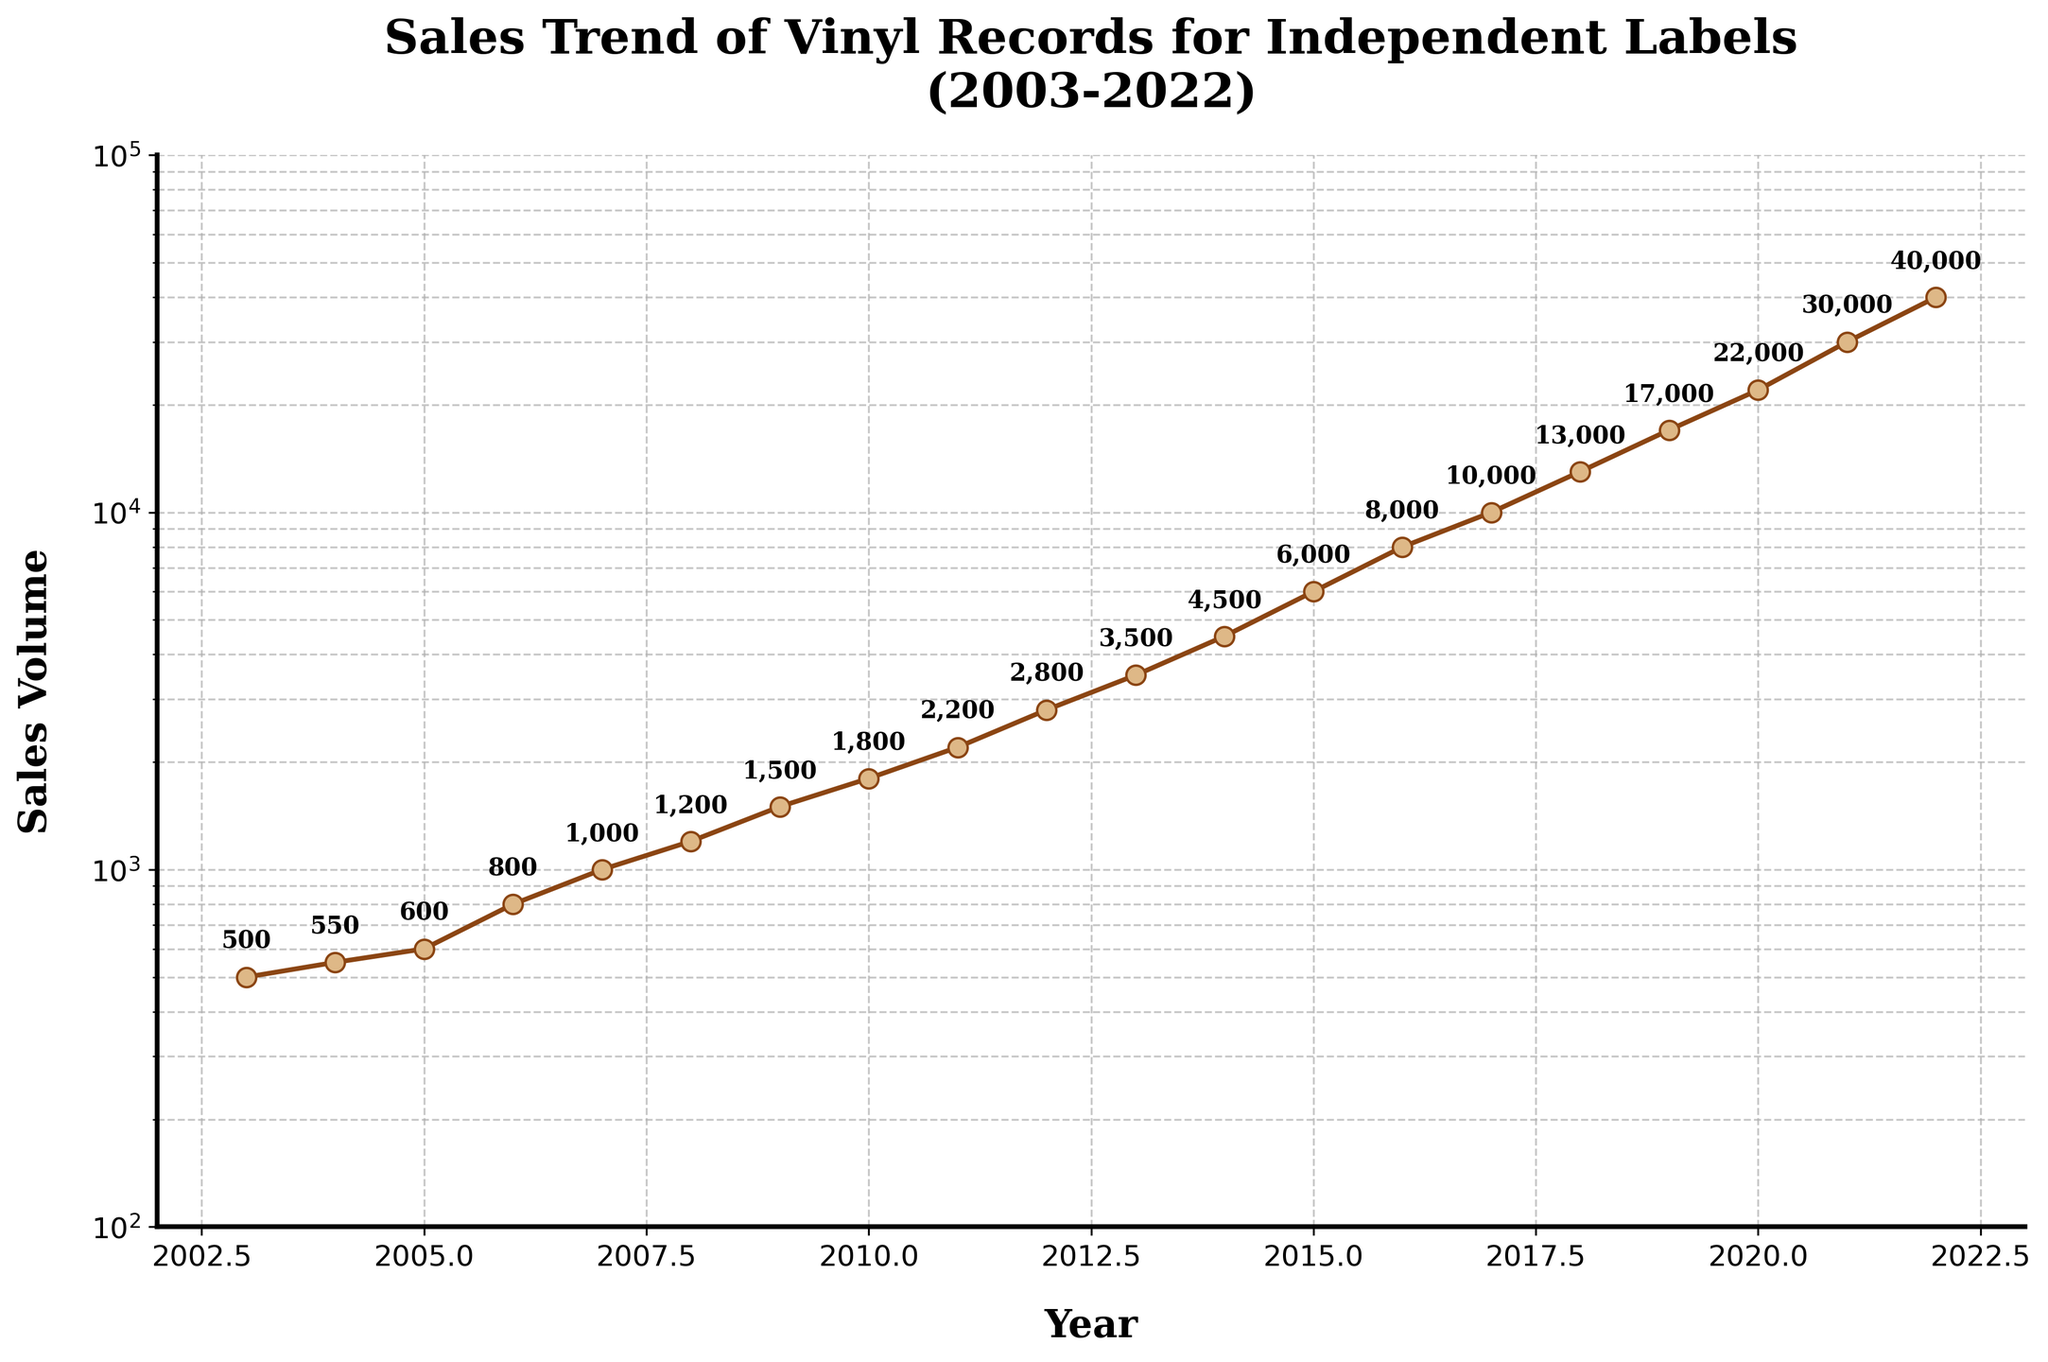What is the title of the plot? The title of the plot is displayed at the top. It reads, "Sales Trend of Vinyl Records for Independent Labels (2003-2022)"
Answer: Sales Trend of Vinyl Records for Independent Labels (2003-2022) How many years are covered in this plot? The x-axis ranges from 2003 to 2022, which covers 20 years.
Answer: 20 What is the sales volume in the year 2016? By looking at the data point for the year 2016 on the plot, the sales volume is shown as 8,000.
Answer: 8,000 How does the sales volume in 2010 compare to 2020? In 2010, the sales volume is 1,800, whereas in 2020, it is 22,000. 22,000 is significantly higher than 1,800.
Answer: 2020 is much higher than 2010 Which year shows the highest sales volume? The highest sales volume is highlighted in the last year of the plot, which is 2022, showing a value of 40,000.
Answer: 2022 Between which consecutive years did the sales volume experience the most significant increase? The most significant increase between two years can be seen from 2020 (22,000) to 2021 (30,000), adding 8,000 units.
Answer: 2020 to 2021 What is the general trend of the sales volume over the 20-year period? The general trend shows a steady increase in sales volume, with a noticeable acceleration in recent years.
Answer: Steady increase How many individual data points are marked on the plot? Each year from 2003 to 2022 is marked with a data point, totaling 20 points.
Answer: 20 What is the approximate range of sales volumes on the y-axis? The y-axis is logarithmic, ranging from just below 100 to 100,000.
Answer: 100 to 100,000 Comparing 2003 and 2013, how much did the sales volume increase by? In 2003, the sales volume was 500, and in 2013 it was 3,500. The increase is 3,500 - 500 = 3,000.
Answer: 3,000 